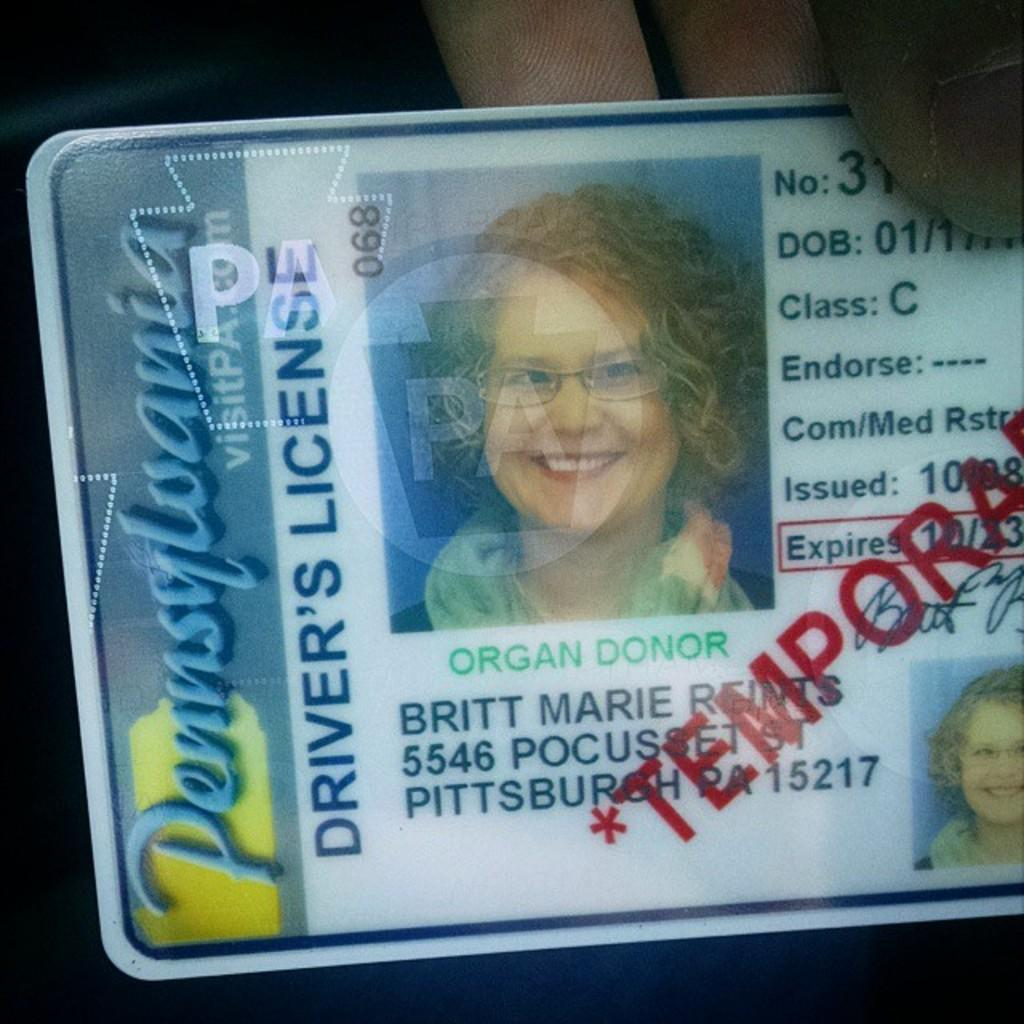What is the main object in the picture? There is a driving license in the picture. To whom does the driving license belong? The driving license belongs to a person. How is the driving license being held in the image? The driving license is being held in someone's hand. What type of cheese can be seen on the paper in the image? There is no cheese or paper present in the image; it only features a driving license. 